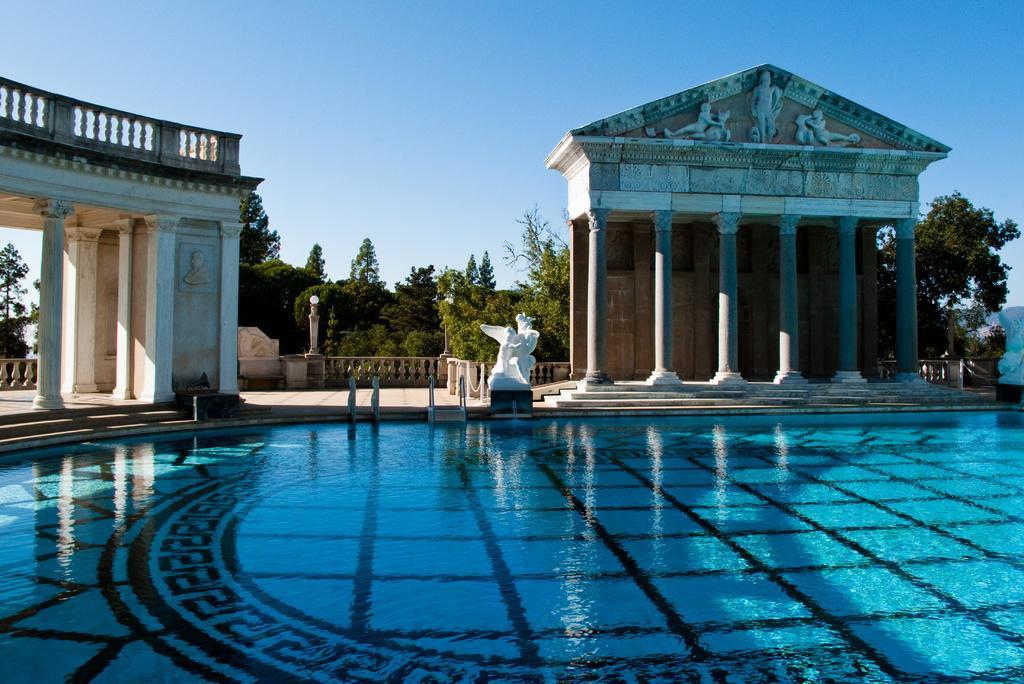Describe this image in one or two sentences. At the bottom there is a swimming pool, in the middle there are statues. These are the trees, at the top it is the sky. 